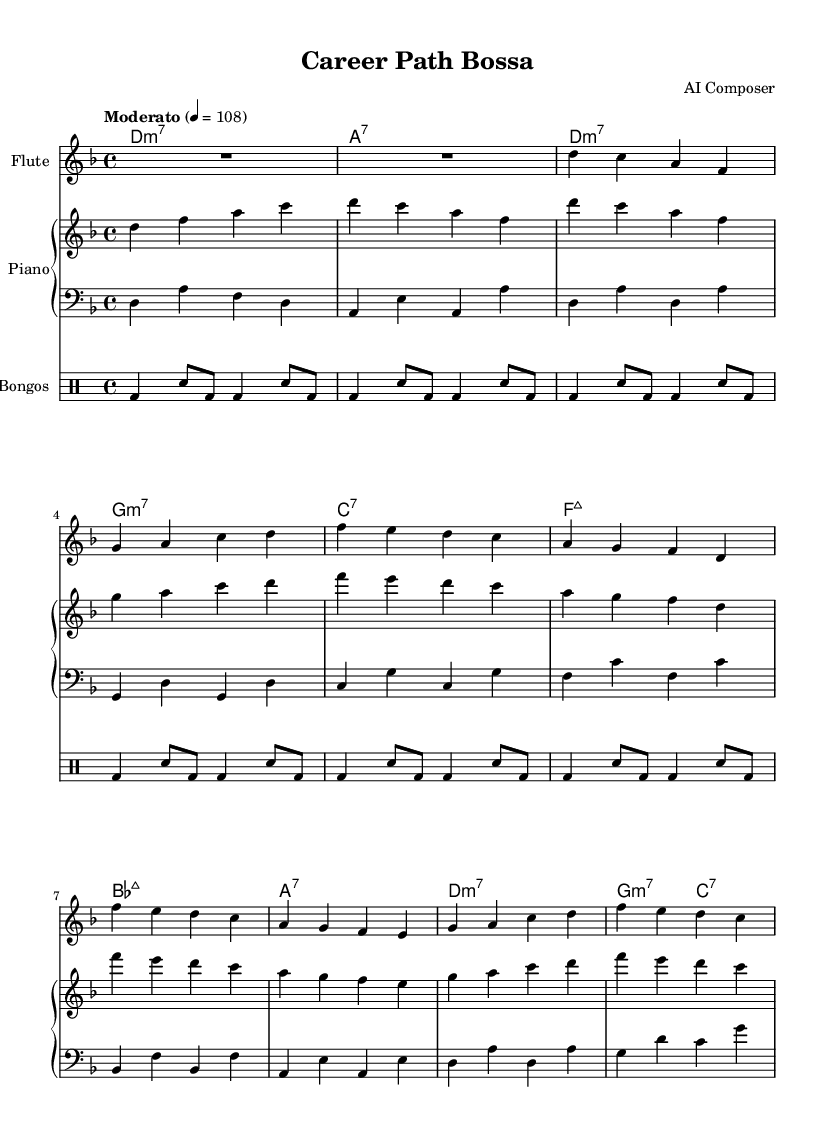What is the key signature of this music? The key signature is D minor, indicated by one flat (B♭) in the key signature at the beginning of the staff.
Answer: D minor What is the time signature of this music? The time signature, located at the beginning of the sheet music, is 4/4, meaning there are four beats in each measure and the quarter note receives one beat.
Answer: 4/4 What is the tempo marking of this music? The tempo marking states "Moderato" with a metronome marking of 108 beats per minute, indicating a moderate speed.
Answer: Moderato How many measures are in the flute part? By counting the measures in the flute staff, there are a total of 8 measures represented in the music.
Answer: 8 What is the first chord in the harmony? The first chord in the chord section is D minor seventh (D:m7), as indicated by the chord notation at the start of the harmonic progression.
Answer: D:m7 What instrument plays the bass part? The bass part is played by the bass guitar, which is typically indicated by the clef marked as "bass" in the score.
Answer: Bass What type of rhythm pattern is used in the bongos? The rhythm pattern is characterized by a repetitive bongo strike in a combination of bass and snare patterns, primarily focusing on a steady beat throughout the measure.
Answer: Bongo rhythm 